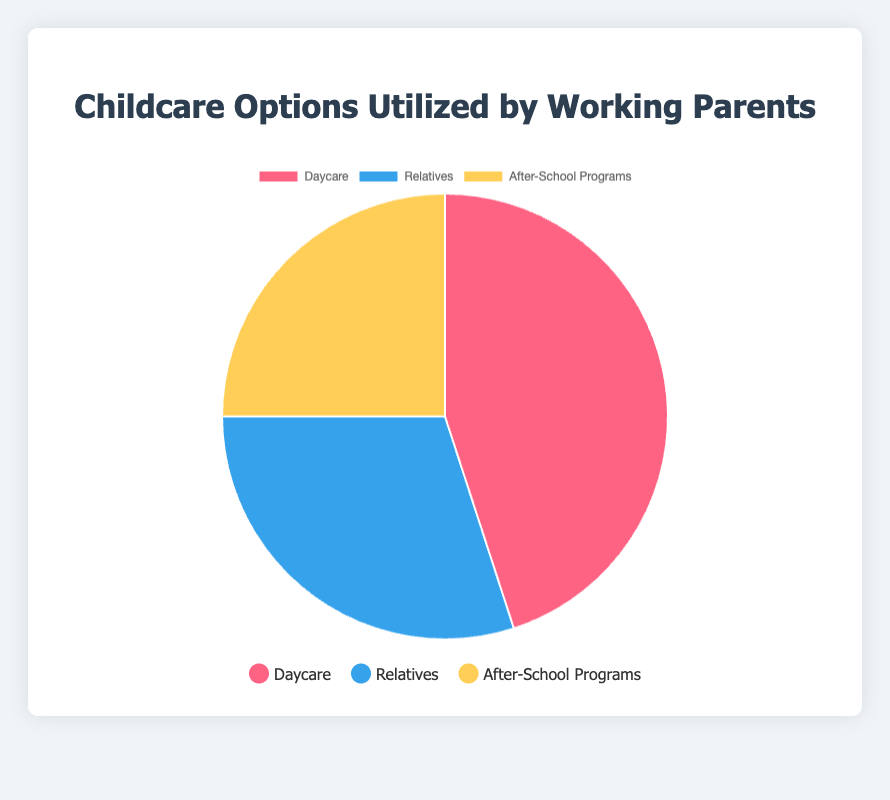Which childcare option is utilized the most? The pie chart shows the percentage distribution of three childcare options. Daycare has the highest percentage at 45%, compared to Relatives at 30% and After-School Programs at 25%.
Answer: Daycare Which childcare option is utilized the least? The pie chart shows the percentage distribution of three childcare options. After-School Programs has the lowest percentage at 25%, compared to Daycare at 45% and Relatives at 30%.
Answer: After-School Programs What is the combined percentage of Relatives and After-School Programs? To find the combined percentage of Relatives and After-School Programs, add their respective percentages. Relatives is 30% and After-School Programs is 25%, so 30% + 25% = 55%.
Answer: 55% How much more utilized is Daycare compared to After-School Programs? The percentage for Daycare is 45% and for After-School Programs is 25%. To find the difference, subtract 25% from 45%, which is 45% - 25% = 20%. Daycare is utilized 20% more.
Answer: 20% Which childcare option is utilized more, Daycare or Relatives? By how much? Daycare is utilized at 45% and Relatives at 30%. To find the difference, subtract 30% from 45%, which is 45% - 30% = 15%. Daycare is utilized 15% more than Relatives.
Answer: Daycare by 15% If the utilization of After-School Programs increased by 10%, what would be the new percentage for After-School Programs? The original percentage for After-School Programs is 25%. Adding 10% to this value would result in 25% + 10% = 35%.
Answer: 35% Out of these three options, which colors represent Daycare and Relatives? The legend in the pie chart specifies that Daycare is represented by the color red and Relatives by the color blue.
Answer: Red for Daycare, Blue for Relatives What is the average percentage utilization across all three childcare options? To find the average, sum the percentages of all three options and divide by 3. So, (45% + 30% + 25%) / 3 = 100% / 3 = approximately 33.33%.
Answer: 33.33% What percentage of the total does the most and the least utilized childcare options account for combined? The most utilized is Daycare at 45% and the least utilized is After-School Programs at 25%. Adding these together gives 45% + 25% = 70%.
Answer: 70% What percentage of the total does the option utilized by relatives account for? According to the pie chart, the percentage for Relatives is 30%.
Answer: 30% 